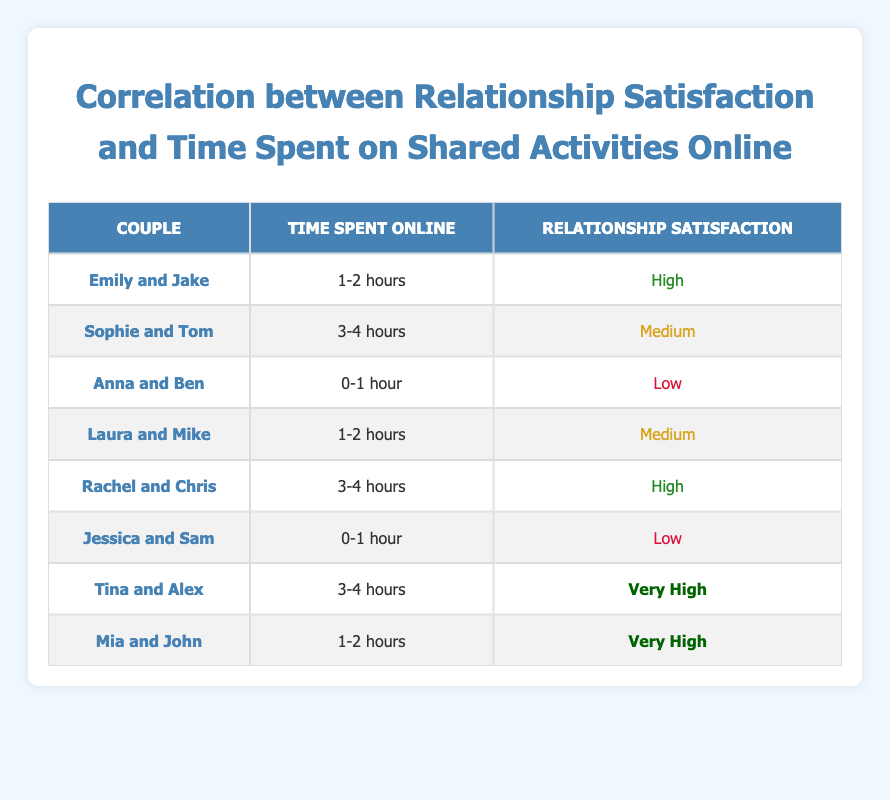What is the relationship satisfaction of the couple Mia and John? Mia and John are listed in the table under "Couple" with a corresponding "Relationship Satisfaction" of "Very High". Therefore, their relationship satisfaction is indeed "Very High".
Answer: Very High How many couples reported "Low" relationship satisfaction? By looking at the "Relationship Satisfaction" column, I can see that there are two couples listed as having "Low" satisfaction: Anna and Ben, and Jessica and Sam. Therefore, the count of couples with "Low" satisfaction is 2.
Answer: 2 What is the average satisfaction level of couples who spent 3-4 hours online? The couples who spent 3-4 hours online are Sophie and Tom (Medium), Rachel and Chris (High), and Tina and Alex (Very High). To assign numerical values: Low (1), Medium (2), High (3), Very High (4). Their respective scores are 2, 3, and 4. The average is (2 + 3 + 4) / 3 = 3, which corresponds to High satisfaction.
Answer: High Is it true that all couples who spent 0-1 hour online have "Low" relationship satisfaction? Checking the "Time Spent Online" column, both Anna and Ben, and Jessica and Sam are the only couples listed as spending 0-1 hour online, and both report "Low" relationship satisfaction. Therefore, the statement is true.
Answer: Yes How does the relationship satisfaction of couples who spend 1-2 hours online compare with those who spend 3-4 hours? Couples who spent 1-2 hours, Emily and Jake (High), Laura and Mike (Medium), and Mia and John (Very High) report an average satisfaction of (3 + 2 + 4) / 3 = 3 (High). Couples spending 3-4 hours, Sophie and Tom (Medium), Rachel and Chris (High), and Tina and Alex (Very High) also average (2 + 3 + 4) / 3 = 3 (High). Thus both groups show similar average satisfaction, which is High.
Answer: Both groups show High satisfaction 